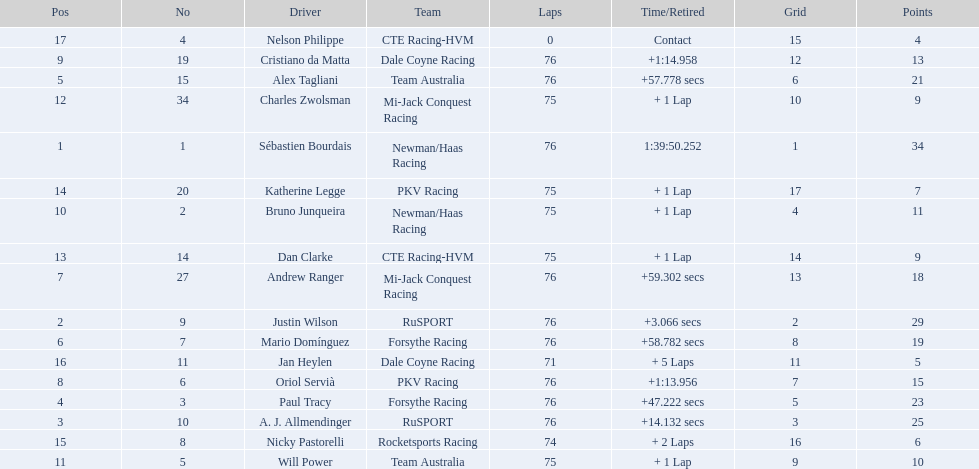Who drove during the 2006 tecate grand prix of monterrey? Sébastien Bourdais, Justin Wilson, A. J. Allmendinger, Paul Tracy, Alex Tagliani, Mario Domínguez, Andrew Ranger, Oriol Servià, Cristiano da Matta, Bruno Junqueira, Will Power, Charles Zwolsman, Dan Clarke, Katherine Legge, Nicky Pastorelli, Jan Heylen, Nelson Philippe. And what were their finishing positions? 1, 2, 3, 4, 5, 6, 7, 8, 9, 10, 11, 12, 13, 14, 15, 16, 17. Who did alex tagliani finish directly behind of? Paul Tracy. 